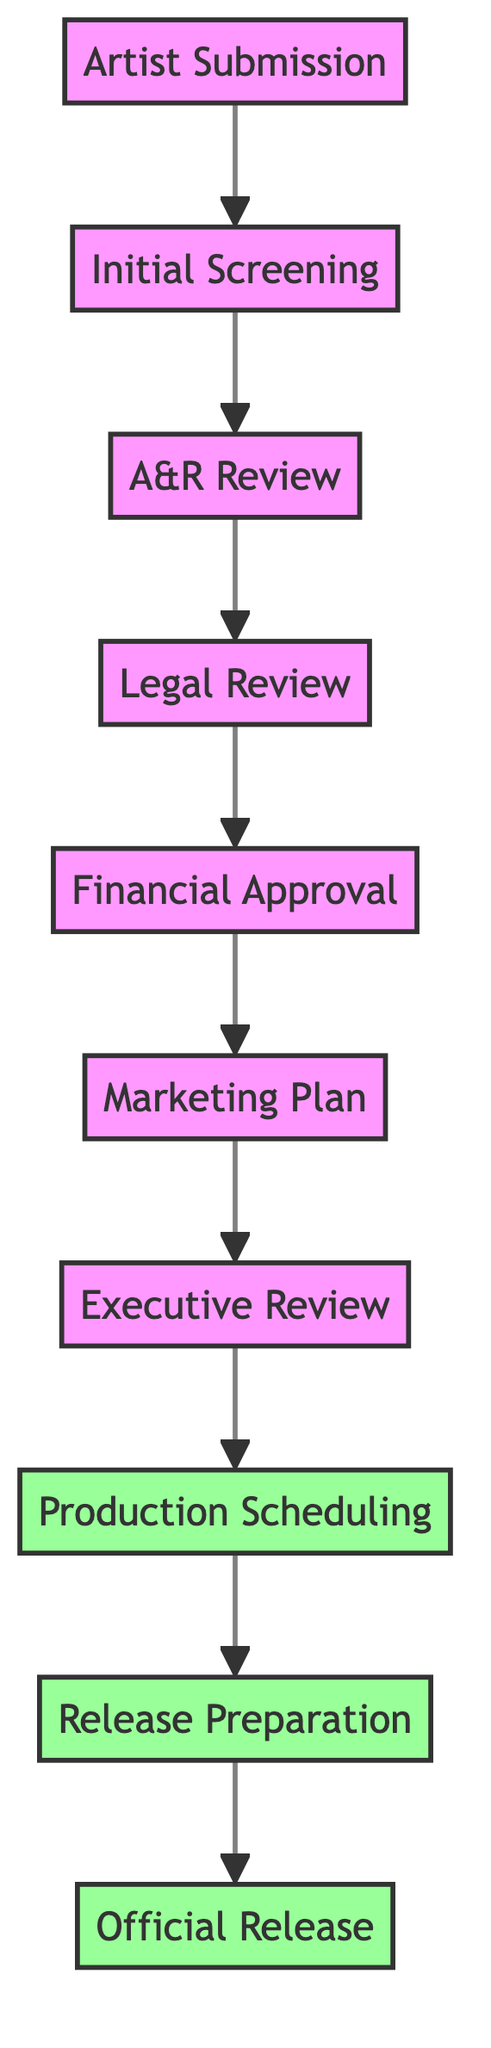What is the first step in the workflow? The first step according to the diagram is "Artist Submission," which is the initial action taken in the process.
Answer: Artist Submission How many nodes are there in total? By counting the individual steps in the diagram, we find that there are 10 distinct nodes representing different stages in the workflow.
Answer: 10 What follows after the A&R Review? The diagram indicates that after "A&R Review," the next step in the process is "Legal Review."
Answer: Legal Review Which node represents the final approval stage? The final approval stage is represented by the "Executive Review" node, where the executive committee grants approval or disapproval.
Answer: Executive Review How many steps lead to the Official Release? From the diagram, there are 9 steps leading to the "Official Release," starting from "Artist Submission" and leading to the final stage.
Answer: 9 What is the last step before the Official Release? According to the diagram, the last step before reaching "Official Release" is "Release Preparation."
Answer: Release Preparation What team is responsible for drafting the Marketing Plan? The "Marketing Plan" node indicates that the Marketing team is tasked with drafting the promotion and distribution strategy.
Answer: Marketing team Is the Production Scheduling step approved or not? The "Production Scheduling" node is colored to indicate that it is an approved step in the workflow, confirming it has passed through the necessary reviews.
Answer: Approved What is the sequence of reviews that the music goes through? The sequence of reviews is: A&R Review, Legal Review, Financial Approval, Marketing Plan, Executive Review. These steps are interlinked in the directed graph leading to the final release.
Answer: A&R Review, Legal Review, Financial Approval, Marketing Plan, Executive Review 